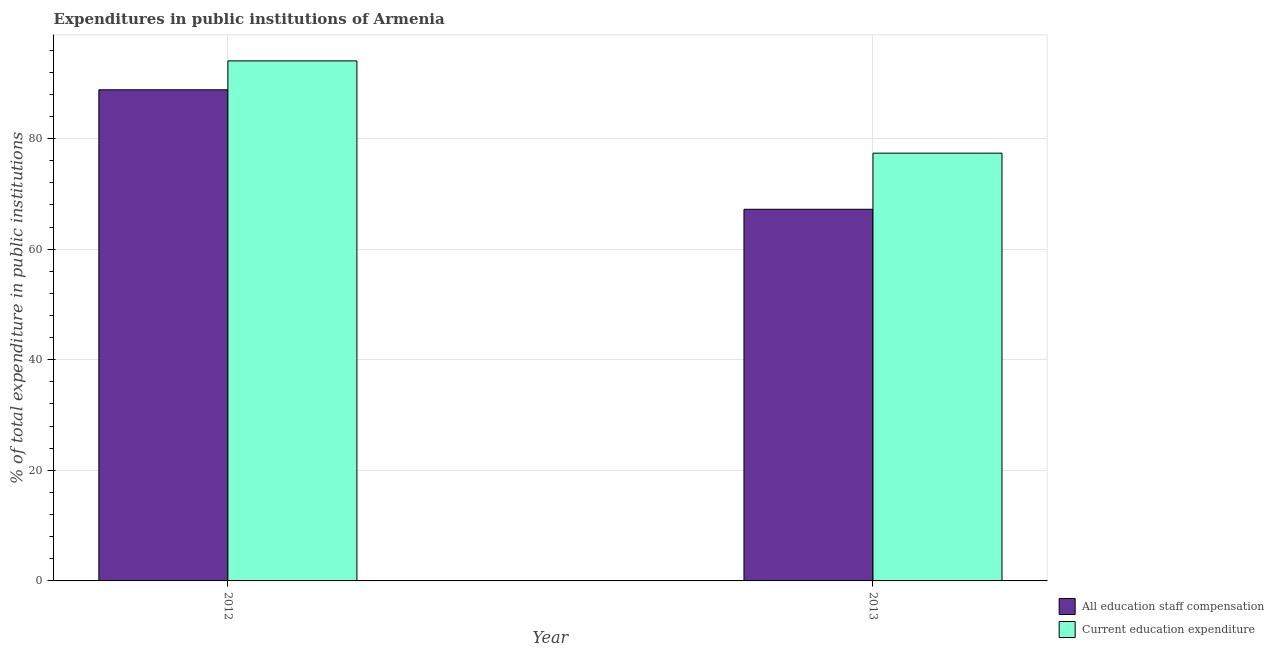How many different coloured bars are there?
Ensure brevity in your answer.  2. How many groups of bars are there?
Offer a terse response. 2. Are the number of bars on each tick of the X-axis equal?
Give a very brief answer. Yes. How many bars are there on the 2nd tick from the right?
Provide a succinct answer. 2. What is the expenditure in education in 2013?
Keep it short and to the point. 77.35. Across all years, what is the maximum expenditure in education?
Offer a very short reply. 94.04. Across all years, what is the minimum expenditure in staff compensation?
Your response must be concise. 67.2. In which year was the expenditure in education maximum?
Provide a succinct answer. 2012. In which year was the expenditure in staff compensation minimum?
Your response must be concise. 2013. What is the total expenditure in education in the graph?
Your answer should be very brief. 171.39. What is the difference between the expenditure in education in 2012 and that in 2013?
Make the answer very short. 16.69. What is the difference between the expenditure in education in 2013 and the expenditure in staff compensation in 2012?
Your response must be concise. -16.69. What is the average expenditure in staff compensation per year?
Your response must be concise. 78.01. What is the ratio of the expenditure in staff compensation in 2012 to that in 2013?
Your answer should be compact. 1.32. In how many years, is the expenditure in staff compensation greater than the average expenditure in staff compensation taken over all years?
Your answer should be very brief. 1. What does the 1st bar from the left in 2012 represents?
Your answer should be very brief. All education staff compensation. What does the 1st bar from the right in 2012 represents?
Give a very brief answer. Current education expenditure. Are all the bars in the graph horizontal?
Ensure brevity in your answer.  No. What is the difference between two consecutive major ticks on the Y-axis?
Give a very brief answer. 20. Does the graph contain grids?
Your answer should be very brief. Yes. How many legend labels are there?
Ensure brevity in your answer.  2. How are the legend labels stacked?
Provide a short and direct response. Vertical. What is the title of the graph?
Your answer should be very brief. Expenditures in public institutions of Armenia. Does "International Visitors" appear as one of the legend labels in the graph?
Make the answer very short. No. What is the label or title of the X-axis?
Offer a terse response. Year. What is the label or title of the Y-axis?
Provide a short and direct response. % of total expenditure in public institutions. What is the % of total expenditure in public institutions in All education staff compensation in 2012?
Offer a very short reply. 88.81. What is the % of total expenditure in public institutions in Current education expenditure in 2012?
Your answer should be very brief. 94.04. What is the % of total expenditure in public institutions of All education staff compensation in 2013?
Offer a terse response. 67.2. What is the % of total expenditure in public institutions in Current education expenditure in 2013?
Your answer should be very brief. 77.35. Across all years, what is the maximum % of total expenditure in public institutions of All education staff compensation?
Your answer should be compact. 88.81. Across all years, what is the maximum % of total expenditure in public institutions in Current education expenditure?
Your answer should be very brief. 94.04. Across all years, what is the minimum % of total expenditure in public institutions of All education staff compensation?
Offer a very short reply. 67.2. Across all years, what is the minimum % of total expenditure in public institutions of Current education expenditure?
Ensure brevity in your answer.  77.35. What is the total % of total expenditure in public institutions in All education staff compensation in the graph?
Your answer should be compact. 156.02. What is the total % of total expenditure in public institutions in Current education expenditure in the graph?
Your response must be concise. 171.39. What is the difference between the % of total expenditure in public institutions in All education staff compensation in 2012 and that in 2013?
Offer a terse response. 21.61. What is the difference between the % of total expenditure in public institutions in Current education expenditure in 2012 and that in 2013?
Your answer should be compact. 16.69. What is the difference between the % of total expenditure in public institutions of All education staff compensation in 2012 and the % of total expenditure in public institutions of Current education expenditure in 2013?
Ensure brevity in your answer.  11.46. What is the average % of total expenditure in public institutions of All education staff compensation per year?
Your answer should be very brief. 78.01. What is the average % of total expenditure in public institutions of Current education expenditure per year?
Your response must be concise. 85.7. In the year 2012, what is the difference between the % of total expenditure in public institutions of All education staff compensation and % of total expenditure in public institutions of Current education expenditure?
Ensure brevity in your answer.  -5.23. In the year 2013, what is the difference between the % of total expenditure in public institutions of All education staff compensation and % of total expenditure in public institutions of Current education expenditure?
Make the answer very short. -10.15. What is the ratio of the % of total expenditure in public institutions in All education staff compensation in 2012 to that in 2013?
Your response must be concise. 1.32. What is the ratio of the % of total expenditure in public institutions in Current education expenditure in 2012 to that in 2013?
Offer a very short reply. 1.22. What is the difference between the highest and the second highest % of total expenditure in public institutions of All education staff compensation?
Provide a succinct answer. 21.61. What is the difference between the highest and the second highest % of total expenditure in public institutions of Current education expenditure?
Offer a terse response. 16.69. What is the difference between the highest and the lowest % of total expenditure in public institutions in All education staff compensation?
Ensure brevity in your answer.  21.61. What is the difference between the highest and the lowest % of total expenditure in public institutions in Current education expenditure?
Your response must be concise. 16.69. 